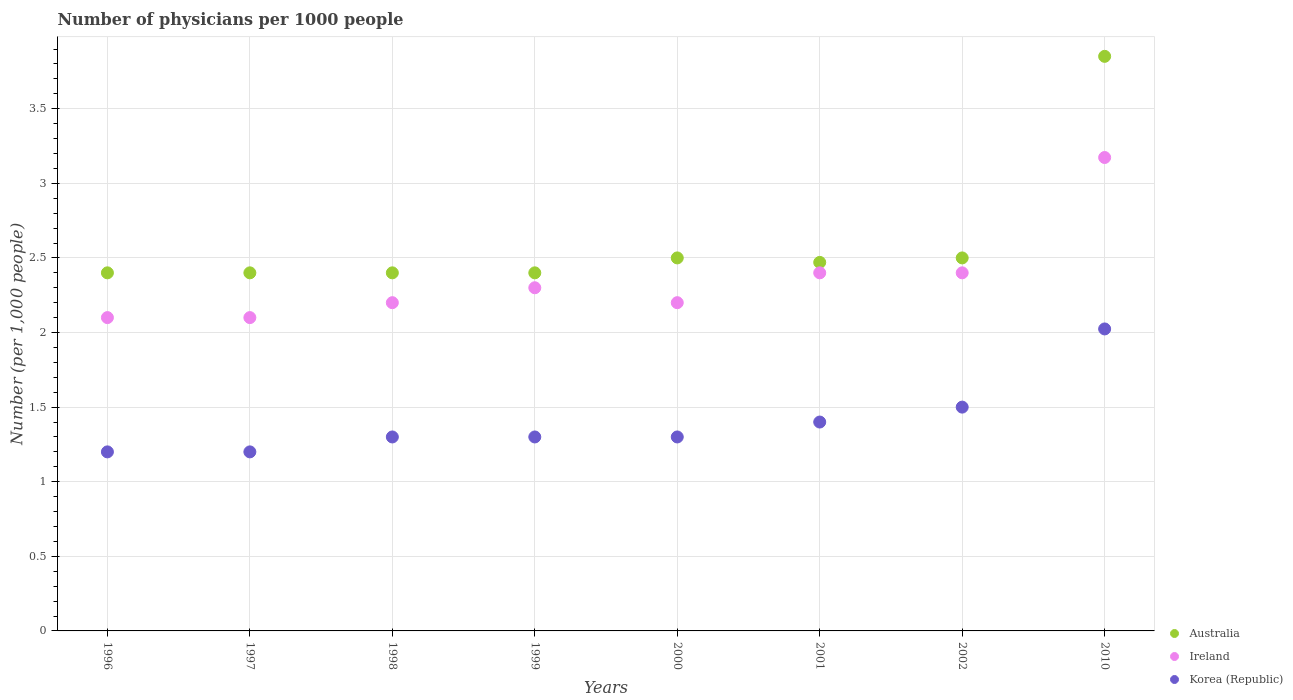Is the number of dotlines equal to the number of legend labels?
Offer a very short reply. Yes. Across all years, what is the maximum number of physicians in Australia?
Your response must be concise. 3.85. In which year was the number of physicians in Korea (Republic) maximum?
Offer a very short reply. 2010. In which year was the number of physicians in Australia minimum?
Offer a terse response. 1996. What is the total number of physicians in Australia in the graph?
Offer a very short reply. 20.92. What is the difference between the number of physicians in Korea (Republic) in 1997 and that in 1998?
Give a very brief answer. -0.1. What is the difference between the number of physicians in Korea (Republic) in 1997 and the number of physicians in Ireland in 1996?
Keep it short and to the point. -0.9. What is the average number of physicians in Australia per year?
Offer a very short reply. 2.62. In the year 2000, what is the difference between the number of physicians in Ireland and number of physicians in Australia?
Keep it short and to the point. -0.3. What is the ratio of the number of physicians in Ireland in 1998 to that in 2010?
Offer a very short reply. 0.69. Is the number of physicians in Australia in 1998 less than that in 2001?
Ensure brevity in your answer.  Yes. What is the difference between the highest and the second highest number of physicians in Australia?
Provide a short and direct response. 1.35. What is the difference between the highest and the lowest number of physicians in Australia?
Keep it short and to the point. 1.45. Is the sum of the number of physicians in Australia in 1998 and 2002 greater than the maximum number of physicians in Korea (Republic) across all years?
Offer a terse response. Yes. Is it the case that in every year, the sum of the number of physicians in Ireland and number of physicians in Australia  is greater than the number of physicians in Korea (Republic)?
Your answer should be compact. Yes. Does the number of physicians in Korea (Republic) monotonically increase over the years?
Give a very brief answer. No. Is the number of physicians in Korea (Republic) strictly greater than the number of physicians in Ireland over the years?
Provide a short and direct response. No. How many years are there in the graph?
Your answer should be very brief. 8. What is the difference between two consecutive major ticks on the Y-axis?
Offer a very short reply. 0.5. Does the graph contain any zero values?
Offer a very short reply. No. How many legend labels are there?
Your answer should be very brief. 3. How are the legend labels stacked?
Provide a succinct answer. Vertical. What is the title of the graph?
Keep it short and to the point. Number of physicians per 1000 people. What is the label or title of the Y-axis?
Your response must be concise. Number (per 1,0 people). What is the Number (per 1,000 people) in Australia in 1996?
Keep it short and to the point. 2.4. What is the Number (per 1,000 people) in Ireland in 1996?
Provide a short and direct response. 2.1. What is the Number (per 1,000 people) of Ireland in 1997?
Your answer should be compact. 2.1. What is the Number (per 1,000 people) in Korea (Republic) in 1997?
Your answer should be compact. 1.2. What is the Number (per 1,000 people) of Australia in 1998?
Make the answer very short. 2.4. What is the Number (per 1,000 people) in Korea (Republic) in 1998?
Offer a terse response. 1.3. What is the Number (per 1,000 people) of Ireland in 1999?
Offer a very short reply. 2.3. What is the Number (per 1,000 people) of Korea (Republic) in 1999?
Ensure brevity in your answer.  1.3. What is the Number (per 1,000 people) of Korea (Republic) in 2000?
Give a very brief answer. 1.3. What is the Number (per 1,000 people) of Australia in 2001?
Offer a very short reply. 2.47. What is the Number (per 1,000 people) of Australia in 2002?
Your answer should be compact. 2.5. What is the Number (per 1,000 people) of Ireland in 2002?
Keep it short and to the point. 2.4. What is the Number (per 1,000 people) of Australia in 2010?
Provide a short and direct response. 3.85. What is the Number (per 1,000 people) of Ireland in 2010?
Ensure brevity in your answer.  3.17. What is the Number (per 1,000 people) in Korea (Republic) in 2010?
Offer a terse response. 2.02. Across all years, what is the maximum Number (per 1,000 people) of Australia?
Your response must be concise. 3.85. Across all years, what is the maximum Number (per 1,000 people) of Ireland?
Provide a succinct answer. 3.17. Across all years, what is the maximum Number (per 1,000 people) in Korea (Republic)?
Provide a succinct answer. 2.02. Across all years, what is the minimum Number (per 1,000 people) of Australia?
Provide a short and direct response. 2.4. Across all years, what is the minimum Number (per 1,000 people) of Ireland?
Provide a succinct answer. 2.1. Across all years, what is the minimum Number (per 1,000 people) of Korea (Republic)?
Your answer should be very brief. 1.2. What is the total Number (per 1,000 people) of Australia in the graph?
Your response must be concise. 20.92. What is the total Number (per 1,000 people) of Ireland in the graph?
Provide a short and direct response. 18.87. What is the total Number (per 1,000 people) of Korea (Republic) in the graph?
Your response must be concise. 11.22. What is the difference between the Number (per 1,000 people) of Australia in 1996 and that in 1998?
Ensure brevity in your answer.  0. What is the difference between the Number (per 1,000 people) in Korea (Republic) in 1996 and that in 1998?
Ensure brevity in your answer.  -0.1. What is the difference between the Number (per 1,000 people) of Ireland in 1996 and that in 1999?
Keep it short and to the point. -0.2. What is the difference between the Number (per 1,000 people) of Korea (Republic) in 1996 and that in 1999?
Ensure brevity in your answer.  -0.1. What is the difference between the Number (per 1,000 people) in Ireland in 1996 and that in 2000?
Make the answer very short. -0.1. What is the difference between the Number (per 1,000 people) in Australia in 1996 and that in 2001?
Provide a succinct answer. -0.07. What is the difference between the Number (per 1,000 people) in Australia in 1996 and that in 2002?
Make the answer very short. -0.1. What is the difference between the Number (per 1,000 people) in Ireland in 1996 and that in 2002?
Your answer should be compact. -0.3. What is the difference between the Number (per 1,000 people) of Korea (Republic) in 1996 and that in 2002?
Give a very brief answer. -0.3. What is the difference between the Number (per 1,000 people) in Australia in 1996 and that in 2010?
Offer a terse response. -1.45. What is the difference between the Number (per 1,000 people) of Ireland in 1996 and that in 2010?
Provide a succinct answer. -1.07. What is the difference between the Number (per 1,000 people) of Korea (Republic) in 1996 and that in 2010?
Give a very brief answer. -0.82. What is the difference between the Number (per 1,000 people) of Australia in 1997 and that in 1998?
Make the answer very short. 0. What is the difference between the Number (per 1,000 people) of Ireland in 1997 and that in 1998?
Provide a short and direct response. -0.1. What is the difference between the Number (per 1,000 people) of Korea (Republic) in 1997 and that in 1998?
Offer a very short reply. -0.1. What is the difference between the Number (per 1,000 people) of Ireland in 1997 and that in 1999?
Your answer should be very brief. -0.2. What is the difference between the Number (per 1,000 people) of Australia in 1997 and that in 2000?
Provide a short and direct response. -0.1. What is the difference between the Number (per 1,000 people) of Ireland in 1997 and that in 2000?
Provide a short and direct response. -0.1. What is the difference between the Number (per 1,000 people) in Korea (Republic) in 1997 and that in 2000?
Provide a succinct answer. -0.1. What is the difference between the Number (per 1,000 people) of Australia in 1997 and that in 2001?
Your response must be concise. -0.07. What is the difference between the Number (per 1,000 people) in Korea (Republic) in 1997 and that in 2001?
Ensure brevity in your answer.  -0.2. What is the difference between the Number (per 1,000 people) of Australia in 1997 and that in 2002?
Provide a succinct answer. -0.1. What is the difference between the Number (per 1,000 people) in Ireland in 1997 and that in 2002?
Keep it short and to the point. -0.3. What is the difference between the Number (per 1,000 people) in Australia in 1997 and that in 2010?
Offer a terse response. -1.45. What is the difference between the Number (per 1,000 people) of Ireland in 1997 and that in 2010?
Offer a very short reply. -1.07. What is the difference between the Number (per 1,000 people) in Korea (Republic) in 1997 and that in 2010?
Give a very brief answer. -0.82. What is the difference between the Number (per 1,000 people) of Korea (Republic) in 1998 and that in 2000?
Offer a very short reply. 0. What is the difference between the Number (per 1,000 people) in Australia in 1998 and that in 2001?
Provide a short and direct response. -0.07. What is the difference between the Number (per 1,000 people) in Ireland in 1998 and that in 2001?
Keep it short and to the point. -0.2. What is the difference between the Number (per 1,000 people) in Ireland in 1998 and that in 2002?
Ensure brevity in your answer.  -0.2. What is the difference between the Number (per 1,000 people) of Korea (Republic) in 1998 and that in 2002?
Ensure brevity in your answer.  -0.2. What is the difference between the Number (per 1,000 people) of Australia in 1998 and that in 2010?
Your response must be concise. -1.45. What is the difference between the Number (per 1,000 people) of Ireland in 1998 and that in 2010?
Provide a succinct answer. -0.97. What is the difference between the Number (per 1,000 people) of Korea (Republic) in 1998 and that in 2010?
Keep it short and to the point. -0.72. What is the difference between the Number (per 1,000 people) of Australia in 1999 and that in 2000?
Make the answer very short. -0.1. What is the difference between the Number (per 1,000 people) of Ireland in 1999 and that in 2000?
Your answer should be very brief. 0.1. What is the difference between the Number (per 1,000 people) in Australia in 1999 and that in 2001?
Your answer should be compact. -0.07. What is the difference between the Number (per 1,000 people) in Ireland in 1999 and that in 2001?
Offer a very short reply. -0.1. What is the difference between the Number (per 1,000 people) of Australia in 1999 and that in 2002?
Offer a terse response. -0.1. What is the difference between the Number (per 1,000 people) of Ireland in 1999 and that in 2002?
Keep it short and to the point. -0.1. What is the difference between the Number (per 1,000 people) in Korea (Republic) in 1999 and that in 2002?
Ensure brevity in your answer.  -0.2. What is the difference between the Number (per 1,000 people) in Australia in 1999 and that in 2010?
Your answer should be very brief. -1.45. What is the difference between the Number (per 1,000 people) in Ireland in 1999 and that in 2010?
Your response must be concise. -0.87. What is the difference between the Number (per 1,000 people) of Korea (Republic) in 1999 and that in 2010?
Give a very brief answer. -0.72. What is the difference between the Number (per 1,000 people) of Ireland in 2000 and that in 2001?
Ensure brevity in your answer.  -0.2. What is the difference between the Number (per 1,000 people) of Korea (Republic) in 2000 and that in 2001?
Ensure brevity in your answer.  -0.1. What is the difference between the Number (per 1,000 people) in Australia in 2000 and that in 2002?
Ensure brevity in your answer.  0. What is the difference between the Number (per 1,000 people) in Ireland in 2000 and that in 2002?
Provide a succinct answer. -0.2. What is the difference between the Number (per 1,000 people) in Australia in 2000 and that in 2010?
Your answer should be compact. -1.35. What is the difference between the Number (per 1,000 people) in Ireland in 2000 and that in 2010?
Ensure brevity in your answer.  -0.97. What is the difference between the Number (per 1,000 people) of Korea (Republic) in 2000 and that in 2010?
Offer a terse response. -0.72. What is the difference between the Number (per 1,000 people) in Australia in 2001 and that in 2002?
Your answer should be very brief. -0.03. What is the difference between the Number (per 1,000 people) in Ireland in 2001 and that in 2002?
Keep it short and to the point. 0. What is the difference between the Number (per 1,000 people) in Australia in 2001 and that in 2010?
Your answer should be compact. -1.38. What is the difference between the Number (per 1,000 people) of Ireland in 2001 and that in 2010?
Offer a very short reply. -0.77. What is the difference between the Number (per 1,000 people) of Korea (Republic) in 2001 and that in 2010?
Make the answer very short. -0.62. What is the difference between the Number (per 1,000 people) in Australia in 2002 and that in 2010?
Offer a terse response. -1.35. What is the difference between the Number (per 1,000 people) of Ireland in 2002 and that in 2010?
Your answer should be very brief. -0.77. What is the difference between the Number (per 1,000 people) of Korea (Republic) in 2002 and that in 2010?
Your answer should be compact. -0.52. What is the difference between the Number (per 1,000 people) in Ireland in 1996 and the Number (per 1,000 people) in Korea (Republic) in 1997?
Your response must be concise. 0.9. What is the difference between the Number (per 1,000 people) in Ireland in 1996 and the Number (per 1,000 people) in Korea (Republic) in 1999?
Offer a terse response. 0.8. What is the difference between the Number (per 1,000 people) of Ireland in 1996 and the Number (per 1,000 people) of Korea (Republic) in 2002?
Offer a very short reply. 0.6. What is the difference between the Number (per 1,000 people) in Australia in 1996 and the Number (per 1,000 people) in Ireland in 2010?
Your answer should be compact. -0.77. What is the difference between the Number (per 1,000 people) of Australia in 1996 and the Number (per 1,000 people) of Korea (Republic) in 2010?
Ensure brevity in your answer.  0.38. What is the difference between the Number (per 1,000 people) in Ireland in 1996 and the Number (per 1,000 people) in Korea (Republic) in 2010?
Give a very brief answer. 0.08. What is the difference between the Number (per 1,000 people) of Australia in 1997 and the Number (per 1,000 people) of Korea (Republic) in 1999?
Keep it short and to the point. 1.1. What is the difference between the Number (per 1,000 people) of Australia in 1997 and the Number (per 1,000 people) of Ireland in 2000?
Offer a terse response. 0.2. What is the difference between the Number (per 1,000 people) of Australia in 1997 and the Number (per 1,000 people) of Korea (Republic) in 2000?
Offer a very short reply. 1.1. What is the difference between the Number (per 1,000 people) of Australia in 1997 and the Number (per 1,000 people) of Korea (Republic) in 2001?
Your response must be concise. 1. What is the difference between the Number (per 1,000 people) of Australia in 1997 and the Number (per 1,000 people) of Ireland in 2002?
Ensure brevity in your answer.  0. What is the difference between the Number (per 1,000 people) of Australia in 1997 and the Number (per 1,000 people) of Ireland in 2010?
Keep it short and to the point. -0.77. What is the difference between the Number (per 1,000 people) in Australia in 1997 and the Number (per 1,000 people) in Korea (Republic) in 2010?
Ensure brevity in your answer.  0.38. What is the difference between the Number (per 1,000 people) of Ireland in 1997 and the Number (per 1,000 people) of Korea (Republic) in 2010?
Keep it short and to the point. 0.08. What is the difference between the Number (per 1,000 people) in Australia in 1998 and the Number (per 1,000 people) in Ireland in 1999?
Your answer should be compact. 0.1. What is the difference between the Number (per 1,000 people) in Australia in 1998 and the Number (per 1,000 people) in Korea (Republic) in 1999?
Keep it short and to the point. 1.1. What is the difference between the Number (per 1,000 people) in Australia in 1998 and the Number (per 1,000 people) in Korea (Republic) in 2000?
Ensure brevity in your answer.  1.1. What is the difference between the Number (per 1,000 people) in Ireland in 1998 and the Number (per 1,000 people) in Korea (Republic) in 2000?
Offer a terse response. 0.9. What is the difference between the Number (per 1,000 people) in Australia in 1998 and the Number (per 1,000 people) in Ireland in 2001?
Provide a succinct answer. 0. What is the difference between the Number (per 1,000 people) in Australia in 1998 and the Number (per 1,000 people) in Korea (Republic) in 2001?
Provide a short and direct response. 1. What is the difference between the Number (per 1,000 people) in Ireland in 1998 and the Number (per 1,000 people) in Korea (Republic) in 2001?
Your answer should be very brief. 0.8. What is the difference between the Number (per 1,000 people) of Australia in 1998 and the Number (per 1,000 people) of Korea (Republic) in 2002?
Offer a terse response. 0.9. What is the difference between the Number (per 1,000 people) of Australia in 1998 and the Number (per 1,000 people) of Ireland in 2010?
Ensure brevity in your answer.  -0.77. What is the difference between the Number (per 1,000 people) of Australia in 1998 and the Number (per 1,000 people) of Korea (Republic) in 2010?
Make the answer very short. 0.38. What is the difference between the Number (per 1,000 people) of Ireland in 1998 and the Number (per 1,000 people) of Korea (Republic) in 2010?
Make the answer very short. 0.18. What is the difference between the Number (per 1,000 people) in Australia in 1999 and the Number (per 1,000 people) in Ireland in 2000?
Offer a terse response. 0.2. What is the difference between the Number (per 1,000 people) in Australia in 1999 and the Number (per 1,000 people) in Korea (Republic) in 2000?
Your answer should be very brief. 1.1. What is the difference between the Number (per 1,000 people) of Ireland in 1999 and the Number (per 1,000 people) of Korea (Republic) in 2000?
Your response must be concise. 1. What is the difference between the Number (per 1,000 people) of Ireland in 1999 and the Number (per 1,000 people) of Korea (Republic) in 2001?
Make the answer very short. 0.9. What is the difference between the Number (per 1,000 people) of Australia in 1999 and the Number (per 1,000 people) of Ireland in 2002?
Offer a very short reply. 0. What is the difference between the Number (per 1,000 people) in Australia in 1999 and the Number (per 1,000 people) in Ireland in 2010?
Keep it short and to the point. -0.77. What is the difference between the Number (per 1,000 people) in Australia in 1999 and the Number (per 1,000 people) in Korea (Republic) in 2010?
Offer a very short reply. 0.38. What is the difference between the Number (per 1,000 people) in Ireland in 1999 and the Number (per 1,000 people) in Korea (Republic) in 2010?
Provide a succinct answer. 0.28. What is the difference between the Number (per 1,000 people) in Australia in 2000 and the Number (per 1,000 people) in Korea (Republic) in 2001?
Ensure brevity in your answer.  1.1. What is the difference between the Number (per 1,000 people) in Ireland in 2000 and the Number (per 1,000 people) in Korea (Republic) in 2001?
Offer a very short reply. 0.8. What is the difference between the Number (per 1,000 people) in Australia in 2000 and the Number (per 1,000 people) in Ireland in 2002?
Your answer should be compact. 0.1. What is the difference between the Number (per 1,000 people) of Australia in 2000 and the Number (per 1,000 people) of Korea (Republic) in 2002?
Give a very brief answer. 1. What is the difference between the Number (per 1,000 people) in Australia in 2000 and the Number (per 1,000 people) in Ireland in 2010?
Provide a short and direct response. -0.67. What is the difference between the Number (per 1,000 people) of Australia in 2000 and the Number (per 1,000 people) of Korea (Republic) in 2010?
Make the answer very short. 0.48. What is the difference between the Number (per 1,000 people) in Ireland in 2000 and the Number (per 1,000 people) in Korea (Republic) in 2010?
Provide a short and direct response. 0.18. What is the difference between the Number (per 1,000 people) of Australia in 2001 and the Number (per 1,000 people) of Ireland in 2002?
Make the answer very short. 0.07. What is the difference between the Number (per 1,000 people) of Australia in 2001 and the Number (per 1,000 people) of Ireland in 2010?
Provide a succinct answer. -0.7. What is the difference between the Number (per 1,000 people) of Australia in 2001 and the Number (per 1,000 people) of Korea (Republic) in 2010?
Ensure brevity in your answer.  0.45. What is the difference between the Number (per 1,000 people) of Ireland in 2001 and the Number (per 1,000 people) of Korea (Republic) in 2010?
Provide a short and direct response. 0.38. What is the difference between the Number (per 1,000 people) in Australia in 2002 and the Number (per 1,000 people) in Ireland in 2010?
Offer a terse response. -0.67. What is the difference between the Number (per 1,000 people) of Australia in 2002 and the Number (per 1,000 people) of Korea (Republic) in 2010?
Ensure brevity in your answer.  0.48. What is the difference between the Number (per 1,000 people) in Ireland in 2002 and the Number (per 1,000 people) in Korea (Republic) in 2010?
Give a very brief answer. 0.38. What is the average Number (per 1,000 people) in Australia per year?
Provide a short and direct response. 2.62. What is the average Number (per 1,000 people) of Ireland per year?
Your response must be concise. 2.36. What is the average Number (per 1,000 people) of Korea (Republic) per year?
Ensure brevity in your answer.  1.4. In the year 1996, what is the difference between the Number (per 1,000 people) of Australia and Number (per 1,000 people) of Ireland?
Your answer should be compact. 0.3. In the year 1996, what is the difference between the Number (per 1,000 people) in Ireland and Number (per 1,000 people) in Korea (Republic)?
Give a very brief answer. 0.9. In the year 1997, what is the difference between the Number (per 1,000 people) in Australia and Number (per 1,000 people) in Ireland?
Offer a terse response. 0.3. In the year 1997, what is the difference between the Number (per 1,000 people) of Australia and Number (per 1,000 people) of Korea (Republic)?
Your answer should be very brief. 1.2. In the year 1998, what is the difference between the Number (per 1,000 people) of Australia and Number (per 1,000 people) of Ireland?
Provide a succinct answer. 0.2. In the year 1999, what is the difference between the Number (per 1,000 people) in Australia and Number (per 1,000 people) in Ireland?
Keep it short and to the point. 0.1. In the year 1999, what is the difference between the Number (per 1,000 people) of Australia and Number (per 1,000 people) of Korea (Republic)?
Provide a short and direct response. 1.1. In the year 2000, what is the difference between the Number (per 1,000 people) of Australia and Number (per 1,000 people) of Ireland?
Your answer should be very brief. 0.3. In the year 2000, what is the difference between the Number (per 1,000 people) in Australia and Number (per 1,000 people) in Korea (Republic)?
Offer a very short reply. 1.2. In the year 2000, what is the difference between the Number (per 1,000 people) of Ireland and Number (per 1,000 people) of Korea (Republic)?
Make the answer very short. 0.9. In the year 2001, what is the difference between the Number (per 1,000 people) of Australia and Number (per 1,000 people) of Ireland?
Your answer should be compact. 0.07. In the year 2001, what is the difference between the Number (per 1,000 people) in Australia and Number (per 1,000 people) in Korea (Republic)?
Provide a succinct answer. 1.07. In the year 2001, what is the difference between the Number (per 1,000 people) in Ireland and Number (per 1,000 people) in Korea (Republic)?
Your answer should be very brief. 1. In the year 2002, what is the difference between the Number (per 1,000 people) of Australia and Number (per 1,000 people) of Ireland?
Your response must be concise. 0.1. In the year 2002, what is the difference between the Number (per 1,000 people) of Australia and Number (per 1,000 people) of Korea (Republic)?
Your answer should be compact. 1. In the year 2010, what is the difference between the Number (per 1,000 people) of Australia and Number (per 1,000 people) of Ireland?
Ensure brevity in your answer.  0.68. In the year 2010, what is the difference between the Number (per 1,000 people) of Australia and Number (per 1,000 people) of Korea (Republic)?
Provide a short and direct response. 1.83. In the year 2010, what is the difference between the Number (per 1,000 people) in Ireland and Number (per 1,000 people) in Korea (Republic)?
Make the answer very short. 1.15. What is the ratio of the Number (per 1,000 people) in Australia in 1996 to that in 1997?
Offer a very short reply. 1. What is the ratio of the Number (per 1,000 people) in Ireland in 1996 to that in 1998?
Your answer should be very brief. 0.95. What is the ratio of the Number (per 1,000 people) in Australia in 1996 to that in 1999?
Your response must be concise. 1. What is the ratio of the Number (per 1,000 people) of Korea (Republic) in 1996 to that in 1999?
Your answer should be very brief. 0.92. What is the ratio of the Number (per 1,000 people) of Ireland in 1996 to that in 2000?
Ensure brevity in your answer.  0.95. What is the ratio of the Number (per 1,000 people) of Australia in 1996 to that in 2001?
Your response must be concise. 0.97. What is the ratio of the Number (per 1,000 people) of Ireland in 1996 to that in 2001?
Your answer should be compact. 0.88. What is the ratio of the Number (per 1,000 people) in Australia in 1996 to that in 2002?
Ensure brevity in your answer.  0.96. What is the ratio of the Number (per 1,000 people) in Australia in 1996 to that in 2010?
Offer a very short reply. 0.62. What is the ratio of the Number (per 1,000 people) in Ireland in 1996 to that in 2010?
Give a very brief answer. 0.66. What is the ratio of the Number (per 1,000 people) in Korea (Republic) in 1996 to that in 2010?
Provide a succinct answer. 0.59. What is the ratio of the Number (per 1,000 people) in Australia in 1997 to that in 1998?
Your answer should be very brief. 1. What is the ratio of the Number (per 1,000 people) in Ireland in 1997 to that in 1998?
Your response must be concise. 0.95. What is the ratio of the Number (per 1,000 people) of Australia in 1997 to that in 1999?
Offer a terse response. 1. What is the ratio of the Number (per 1,000 people) of Ireland in 1997 to that in 2000?
Provide a short and direct response. 0.95. What is the ratio of the Number (per 1,000 people) in Australia in 1997 to that in 2001?
Ensure brevity in your answer.  0.97. What is the ratio of the Number (per 1,000 people) of Ireland in 1997 to that in 2001?
Your response must be concise. 0.88. What is the ratio of the Number (per 1,000 people) in Korea (Republic) in 1997 to that in 2001?
Give a very brief answer. 0.86. What is the ratio of the Number (per 1,000 people) in Australia in 1997 to that in 2010?
Offer a very short reply. 0.62. What is the ratio of the Number (per 1,000 people) in Ireland in 1997 to that in 2010?
Your response must be concise. 0.66. What is the ratio of the Number (per 1,000 people) of Korea (Republic) in 1997 to that in 2010?
Provide a succinct answer. 0.59. What is the ratio of the Number (per 1,000 people) of Australia in 1998 to that in 1999?
Your response must be concise. 1. What is the ratio of the Number (per 1,000 people) in Ireland in 1998 to that in 1999?
Give a very brief answer. 0.96. What is the ratio of the Number (per 1,000 people) in Korea (Republic) in 1998 to that in 1999?
Provide a short and direct response. 1. What is the ratio of the Number (per 1,000 people) of Australia in 1998 to that in 2000?
Provide a succinct answer. 0.96. What is the ratio of the Number (per 1,000 people) in Ireland in 1998 to that in 2000?
Offer a very short reply. 1. What is the ratio of the Number (per 1,000 people) in Australia in 1998 to that in 2001?
Offer a terse response. 0.97. What is the ratio of the Number (per 1,000 people) in Ireland in 1998 to that in 2001?
Your answer should be compact. 0.92. What is the ratio of the Number (per 1,000 people) of Korea (Republic) in 1998 to that in 2001?
Keep it short and to the point. 0.93. What is the ratio of the Number (per 1,000 people) in Australia in 1998 to that in 2002?
Give a very brief answer. 0.96. What is the ratio of the Number (per 1,000 people) of Ireland in 1998 to that in 2002?
Give a very brief answer. 0.92. What is the ratio of the Number (per 1,000 people) of Korea (Republic) in 1998 to that in 2002?
Your answer should be compact. 0.87. What is the ratio of the Number (per 1,000 people) in Australia in 1998 to that in 2010?
Offer a terse response. 0.62. What is the ratio of the Number (per 1,000 people) in Ireland in 1998 to that in 2010?
Ensure brevity in your answer.  0.69. What is the ratio of the Number (per 1,000 people) of Korea (Republic) in 1998 to that in 2010?
Your answer should be very brief. 0.64. What is the ratio of the Number (per 1,000 people) in Ireland in 1999 to that in 2000?
Your answer should be compact. 1.05. What is the ratio of the Number (per 1,000 people) of Australia in 1999 to that in 2001?
Make the answer very short. 0.97. What is the ratio of the Number (per 1,000 people) in Australia in 1999 to that in 2002?
Your answer should be compact. 0.96. What is the ratio of the Number (per 1,000 people) of Ireland in 1999 to that in 2002?
Provide a succinct answer. 0.96. What is the ratio of the Number (per 1,000 people) in Korea (Republic) in 1999 to that in 2002?
Your answer should be very brief. 0.87. What is the ratio of the Number (per 1,000 people) of Australia in 1999 to that in 2010?
Offer a very short reply. 0.62. What is the ratio of the Number (per 1,000 people) of Ireland in 1999 to that in 2010?
Provide a succinct answer. 0.72. What is the ratio of the Number (per 1,000 people) in Korea (Republic) in 1999 to that in 2010?
Ensure brevity in your answer.  0.64. What is the ratio of the Number (per 1,000 people) in Australia in 2000 to that in 2001?
Give a very brief answer. 1.01. What is the ratio of the Number (per 1,000 people) in Australia in 2000 to that in 2002?
Give a very brief answer. 1. What is the ratio of the Number (per 1,000 people) of Ireland in 2000 to that in 2002?
Offer a very short reply. 0.92. What is the ratio of the Number (per 1,000 people) of Korea (Republic) in 2000 to that in 2002?
Your response must be concise. 0.87. What is the ratio of the Number (per 1,000 people) in Australia in 2000 to that in 2010?
Your answer should be compact. 0.65. What is the ratio of the Number (per 1,000 people) in Ireland in 2000 to that in 2010?
Your response must be concise. 0.69. What is the ratio of the Number (per 1,000 people) of Korea (Republic) in 2000 to that in 2010?
Keep it short and to the point. 0.64. What is the ratio of the Number (per 1,000 people) of Ireland in 2001 to that in 2002?
Make the answer very short. 1. What is the ratio of the Number (per 1,000 people) of Korea (Republic) in 2001 to that in 2002?
Your answer should be very brief. 0.93. What is the ratio of the Number (per 1,000 people) of Australia in 2001 to that in 2010?
Offer a terse response. 0.64. What is the ratio of the Number (per 1,000 people) of Ireland in 2001 to that in 2010?
Give a very brief answer. 0.76. What is the ratio of the Number (per 1,000 people) in Korea (Republic) in 2001 to that in 2010?
Your response must be concise. 0.69. What is the ratio of the Number (per 1,000 people) in Australia in 2002 to that in 2010?
Your answer should be very brief. 0.65. What is the ratio of the Number (per 1,000 people) of Ireland in 2002 to that in 2010?
Make the answer very short. 0.76. What is the ratio of the Number (per 1,000 people) of Korea (Republic) in 2002 to that in 2010?
Make the answer very short. 0.74. What is the difference between the highest and the second highest Number (per 1,000 people) of Australia?
Provide a short and direct response. 1.35. What is the difference between the highest and the second highest Number (per 1,000 people) in Ireland?
Give a very brief answer. 0.77. What is the difference between the highest and the second highest Number (per 1,000 people) in Korea (Republic)?
Give a very brief answer. 0.52. What is the difference between the highest and the lowest Number (per 1,000 people) of Australia?
Your answer should be compact. 1.45. What is the difference between the highest and the lowest Number (per 1,000 people) in Ireland?
Give a very brief answer. 1.07. What is the difference between the highest and the lowest Number (per 1,000 people) in Korea (Republic)?
Offer a very short reply. 0.82. 